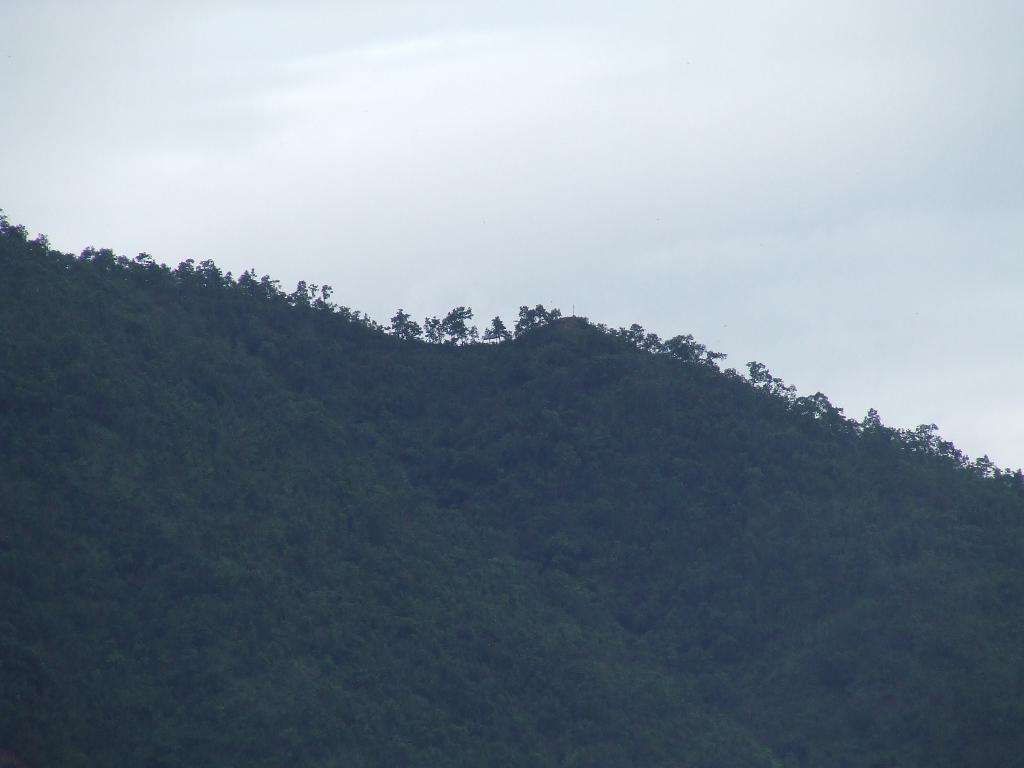Could you give a brief overview of what you see in this image? This image consists of mountain which is covered with plants. At the top, there are clouds in the sky. 